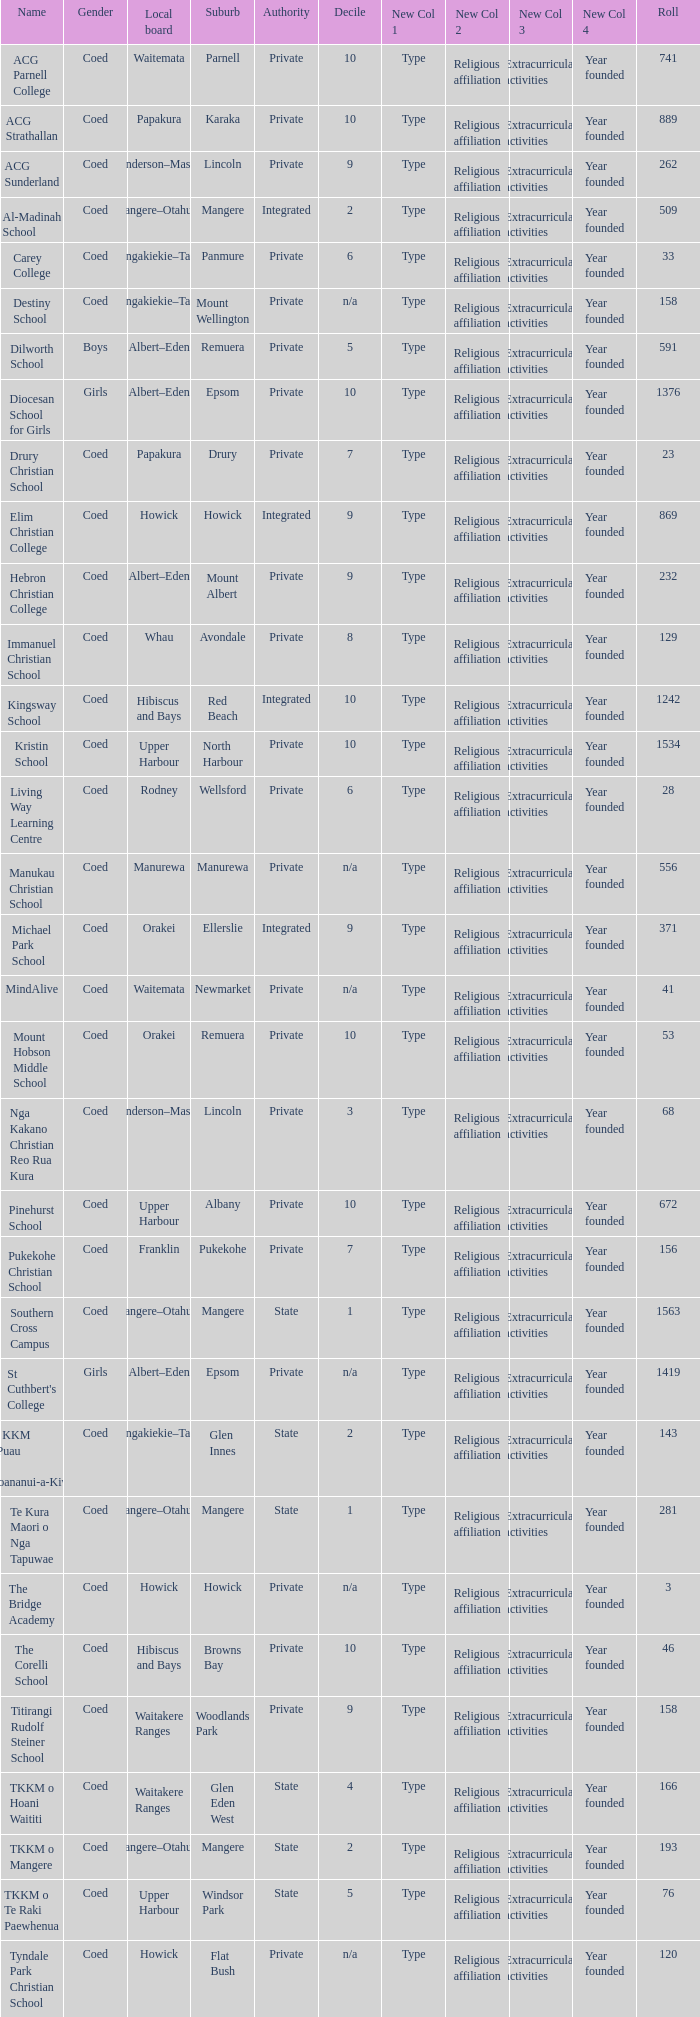What is the name when the local board is albert–eden, and a Decile of 9? Hebron Christian College. 